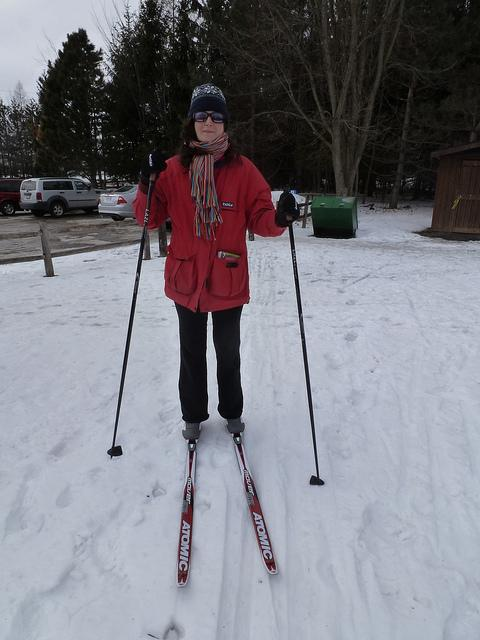Why is the woman wearing the covering around her neck?

Choices:
A) keeping warm
B) covering scar
C) vanity
D) style keeping warm 